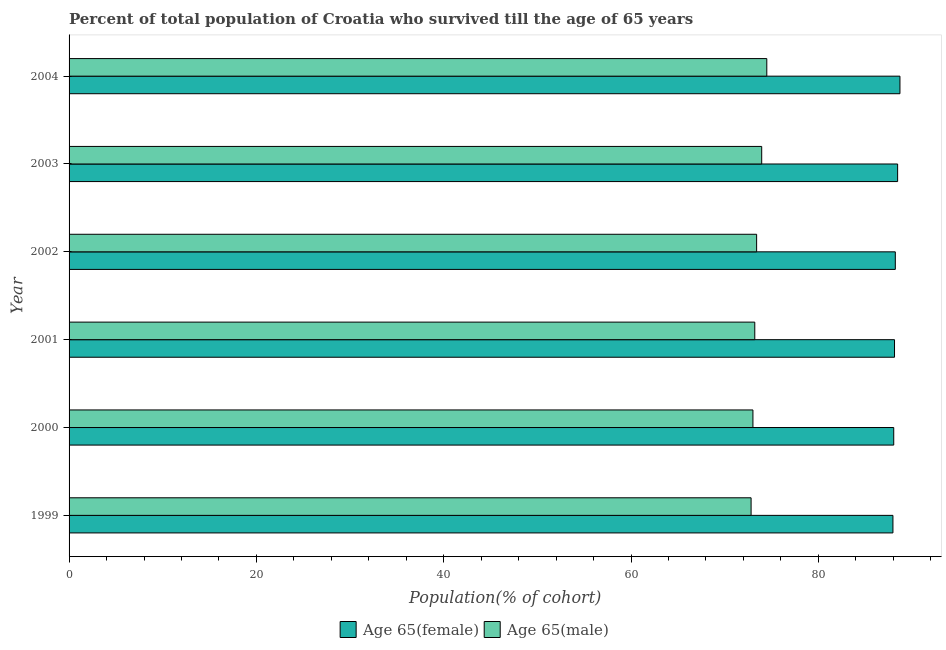How many different coloured bars are there?
Keep it short and to the point. 2. How many groups of bars are there?
Offer a terse response. 6. In how many cases, is the number of bars for a given year not equal to the number of legend labels?
Provide a short and direct response. 0. What is the percentage of male population who survived till age of 65 in 2000?
Provide a short and direct response. 73.02. Across all years, what is the maximum percentage of female population who survived till age of 65?
Ensure brevity in your answer.  88.71. Across all years, what is the minimum percentage of male population who survived till age of 65?
Offer a very short reply. 72.82. In which year was the percentage of male population who survived till age of 65 maximum?
Your answer should be compact. 2004. What is the total percentage of male population who survived till age of 65 in the graph?
Provide a short and direct response. 440.91. What is the difference between the percentage of male population who survived till age of 65 in 2001 and that in 2004?
Ensure brevity in your answer.  -1.28. What is the difference between the percentage of male population who survived till age of 65 in 2002 and the percentage of female population who survived till age of 65 in 2004?
Offer a terse response. -15.3. What is the average percentage of male population who survived till age of 65 per year?
Your answer should be compact. 73.48. In the year 2003, what is the difference between the percentage of female population who survived till age of 65 and percentage of male population who survived till age of 65?
Make the answer very short. 14.51. Is the percentage of male population who survived till age of 65 in 2002 less than that in 2004?
Your response must be concise. Yes. Is the difference between the percentage of male population who survived till age of 65 in 2001 and 2002 greater than the difference between the percentage of female population who survived till age of 65 in 2001 and 2002?
Your response must be concise. No. What is the difference between the highest and the second highest percentage of female population who survived till age of 65?
Make the answer very short. 0.25. What is the difference between the highest and the lowest percentage of male population who survived till age of 65?
Your answer should be compact. 1.68. Is the sum of the percentage of female population who survived till age of 65 in 1999 and 2003 greater than the maximum percentage of male population who survived till age of 65 across all years?
Your answer should be compact. Yes. What does the 2nd bar from the top in 2002 represents?
Provide a short and direct response. Age 65(female). What does the 1st bar from the bottom in 1999 represents?
Offer a very short reply. Age 65(female). How many bars are there?
Keep it short and to the point. 12. How many years are there in the graph?
Make the answer very short. 6. What is the difference between two consecutive major ticks on the X-axis?
Your response must be concise. 20. Does the graph contain any zero values?
Provide a succinct answer. No. Does the graph contain grids?
Provide a short and direct response. No. Where does the legend appear in the graph?
Your answer should be compact. Bottom center. How are the legend labels stacked?
Offer a terse response. Horizontal. What is the title of the graph?
Ensure brevity in your answer.  Percent of total population of Croatia who survived till the age of 65 years. Does "Urban agglomerations" appear as one of the legend labels in the graph?
Make the answer very short. No. What is the label or title of the X-axis?
Provide a short and direct response. Population(% of cohort). What is the Population(% of cohort) in Age 65(female) in 1999?
Make the answer very short. 87.96. What is the Population(% of cohort) of Age 65(male) in 1999?
Offer a terse response. 72.82. What is the Population(% of cohort) in Age 65(female) in 2000?
Make the answer very short. 88.05. What is the Population(% of cohort) in Age 65(male) in 2000?
Your answer should be very brief. 73.02. What is the Population(% of cohort) in Age 65(female) in 2001?
Keep it short and to the point. 88.13. What is the Population(% of cohort) of Age 65(male) in 2001?
Provide a succinct answer. 73.21. What is the Population(% of cohort) in Age 65(female) in 2002?
Give a very brief answer. 88.22. What is the Population(% of cohort) in Age 65(male) in 2002?
Ensure brevity in your answer.  73.41. What is the Population(% of cohort) of Age 65(female) in 2003?
Your answer should be very brief. 88.47. What is the Population(% of cohort) in Age 65(male) in 2003?
Ensure brevity in your answer.  73.95. What is the Population(% of cohort) of Age 65(female) in 2004?
Offer a very short reply. 88.71. What is the Population(% of cohort) of Age 65(male) in 2004?
Offer a very short reply. 74.5. Across all years, what is the maximum Population(% of cohort) in Age 65(female)?
Keep it short and to the point. 88.71. Across all years, what is the maximum Population(% of cohort) of Age 65(male)?
Provide a succinct answer. 74.5. Across all years, what is the minimum Population(% of cohort) of Age 65(female)?
Make the answer very short. 87.96. Across all years, what is the minimum Population(% of cohort) in Age 65(male)?
Your response must be concise. 72.82. What is the total Population(% of cohort) of Age 65(female) in the graph?
Provide a succinct answer. 529.54. What is the total Population(% of cohort) of Age 65(male) in the graph?
Your answer should be very brief. 440.91. What is the difference between the Population(% of cohort) of Age 65(female) in 1999 and that in 2000?
Offer a terse response. -0.08. What is the difference between the Population(% of cohort) of Age 65(male) in 1999 and that in 2000?
Provide a short and direct response. -0.2. What is the difference between the Population(% of cohort) in Age 65(female) in 1999 and that in 2001?
Offer a very short reply. -0.17. What is the difference between the Population(% of cohort) of Age 65(male) in 1999 and that in 2001?
Ensure brevity in your answer.  -0.39. What is the difference between the Population(% of cohort) in Age 65(female) in 1999 and that in 2002?
Ensure brevity in your answer.  -0.25. What is the difference between the Population(% of cohort) of Age 65(male) in 1999 and that in 2002?
Your answer should be very brief. -0.59. What is the difference between the Population(% of cohort) of Age 65(female) in 1999 and that in 2003?
Offer a very short reply. -0.5. What is the difference between the Population(% of cohort) of Age 65(male) in 1999 and that in 2003?
Your response must be concise. -1.13. What is the difference between the Population(% of cohort) of Age 65(female) in 1999 and that in 2004?
Offer a terse response. -0.75. What is the difference between the Population(% of cohort) in Age 65(male) in 1999 and that in 2004?
Offer a very short reply. -1.68. What is the difference between the Population(% of cohort) in Age 65(female) in 2000 and that in 2001?
Offer a terse response. -0.08. What is the difference between the Population(% of cohort) of Age 65(male) in 2000 and that in 2001?
Ensure brevity in your answer.  -0.2. What is the difference between the Population(% of cohort) in Age 65(female) in 2000 and that in 2002?
Give a very brief answer. -0.17. What is the difference between the Population(% of cohort) in Age 65(male) in 2000 and that in 2002?
Give a very brief answer. -0.39. What is the difference between the Population(% of cohort) in Age 65(female) in 2000 and that in 2003?
Give a very brief answer. -0.42. What is the difference between the Population(% of cohort) in Age 65(male) in 2000 and that in 2003?
Ensure brevity in your answer.  -0.94. What is the difference between the Population(% of cohort) in Age 65(female) in 2000 and that in 2004?
Offer a terse response. -0.66. What is the difference between the Population(% of cohort) in Age 65(male) in 2000 and that in 2004?
Keep it short and to the point. -1.48. What is the difference between the Population(% of cohort) of Age 65(female) in 2001 and that in 2002?
Your answer should be compact. -0.08. What is the difference between the Population(% of cohort) in Age 65(male) in 2001 and that in 2002?
Offer a terse response. -0.2. What is the difference between the Population(% of cohort) in Age 65(female) in 2001 and that in 2003?
Offer a very short reply. -0.33. What is the difference between the Population(% of cohort) in Age 65(male) in 2001 and that in 2003?
Give a very brief answer. -0.74. What is the difference between the Population(% of cohort) of Age 65(female) in 2001 and that in 2004?
Your answer should be very brief. -0.58. What is the difference between the Population(% of cohort) in Age 65(male) in 2001 and that in 2004?
Offer a very short reply. -1.28. What is the difference between the Population(% of cohort) of Age 65(female) in 2002 and that in 2003?
Ensure brevity in your answer.  -0.25. What is the difference between the Population(% of cohort) in Age 65(male) in 2002 and that in 2003?
Your response must be concise. -0.54. What is the difference between the Population(% of cohort) in Age 65(female) in 2002 and that in 2004?
Your answer should be very brief. -0.5. What is the difference between the Population(% of cohort) of Age 65(male) in 2002 and that in 2004?
Provide a succinct answer. -1.09. What is the difference between the Population(% of cohort) of Age 65(female) in 2003 and that in 2004?
Give a very brief answer. -0.25. What is the difference between the Population(% of cohort) of Age 65(male) in 2003 and that in 2004?
Offer a very short reply. -0.54. What is the difference between the Population(% of cohort) in Age 65(female) in 1999 and the Population(% of cohort) in Age 65(male) in 2000?
Your response must be concise. 14.95. What is the difference between the Population(% of cohort) of Age 65(female) in 1999 and the Population(% of cohort) of Age 65(male) in 2001?
Keep it short and to the point. 14.75. What is the difference between the Population(% of cohort) in Age 65(female) in 1999 and the Population(% of cohort) in Age 65(male) in 2002?
Your response must be concise. 14.55. What is the difference between the Population(% of cohort) in Age 65(female) in 1999 and the Population(% of cohort) in Age 65(male) in 2003?
Give a very brief answer. 14.01. What is the difference between the Population(% of cohort) of Age 65(female) in 1999 and the Population(% of cohort) of Age 65(male) in 2004?
Give a very brief answer. 13.47. What is the difference between the Population(% of cohort) of Age 65(female) in 2000 and the Population(% of cohort) of Age 65(male) in 2001?
Provide a short and direct response. 14.84. What is the difference between the Population(% of cohort) of Age 65(female) in 2000 and the Population(% of cohort) of Age 65(male) in 2002?
Provide a short and direct response. 14.64. What is the difference between the Population(% of cohort) of Age 65(female) in 2000 and the Population(% of cohort) of Age 65(male) in 2003?
Offer a terse response. 14.1. What is the difference between the Population(% of cohort) in Age 65(female) in 2000 and the Population(% of cohort) in Age 65(male) in 2004?
Your response must be concise. 13.55. What is the difference between the Population(% of cohort) of Age 65(female) in 2001 and the Population(% of cohort) of Age 65(male) in 2002?
Keep it short and to the point. 14.72. What is the difference between the Population(% of cohort) in Age 65(female) in 2001 and the Population(% of cohort) in Age 65(male) in 2003?
Give a very brief answer. 14.18. What is the difference between the Population(% of cohort) of Age 65(female) in 2001 and the Population(% of cohort) of Age 65(male) in 2004?
Provide a succinct answer. 13.64. What is the difference between the Population(% of cohort) in Age 65(female) in 2002 and the Population(% of cohort) in Age 65(male) in 2003?
Your response must be concise. 14.26. What is the difference between the Population(% of cohort) of Age 65(female) in 2002 and the Population(% of cohort) of Age 65(male) in 2004?
Your response must be concise. 13.72. What is the difference between the Population(% of cohort) in Age 65(female) in 2003 and the Population(% of cohort) in Age 65(male) in 2004?
Keep it short and to the point. 13.97. What is the average Population(% of cohort) in Age 65(female) per year?
Your answer should be very brief. 88.26. What is the average Population(% of cohort) of Age 65(male) per year?
Keep it short and to the point. 73.49. In the year 1999, what is the difference between the Population(% of cohort) in Age 65(female) and Population(% of cohort) in Age 65(male)?
Give a very brief answer. 15.14. In the year 2000, what is the difference between the Population(% of cohort) of Age 65(female) and Population(% of cohort) of Age 65(male)?
Provide a short and direct response. 15.03. In the year 2001, what is the difference between the Population(% of cohort) in Age 65(female) and Population(% of cohort) in Age 65(male)?
Your answer should be very brief. 14.92. In the year 2002, what is the difference between the Population(% of cohort) of Age 65(female) and Population(% of cohort) of Age 65(male)?
Keep it short and to the point. 14.81. In the year 2003, what is the difference between the Population(% of cohort) in Age 65(female) and Population(% of cohort) in Age 65(male)?
Provide a succinct answer. 14.51. In the year 2004, what is the difference between the Population(% of cohort) of Age 65(female) and Population(% of cohort) of Age 65(male)?
Offer a very short reply. 14.22. What is the ratio of the Population(% of cohort) in Age 65(male) in 1999 to that in 2000?
Keep it short and to the point. 1. What is the ratio of the Population(% of cohort) in Age 65(female) in 1999 to that in 2001?
Give a very brief answer. 1. What is the ratio of the Population(% of cohort) in Age 65(female) in 1999 to that in 2002?
Provide a succinct answer. 1. What is the ratio of the Population(% of cohort) in Age 65(male) in 1999 to that in 2003?
Give a very brief answer. 0.98. What is the ratio of the Population(% of cohort) of Age 65(male) in 1999 to that in 2004?
Provide a succinct answer. 0.98. What is the ratio of the Population(% of cohort) of Age 65(female) in 2000 to that in 2001?
Make the answer very short. 1. What is the ratio of the Population(% of cohort) of Age 65(male) in 2000 to that in 2001?
Offer a terse response. 1. What is the ratio of the Population(% of cohort) in Age 65(male) in 2000 to that in 2002?
Your answer should be compact. 0.99. What is the ratio of the Population(% of cohort) in Age 65(female) in 2000 to that in 2003?
Offer a very short reply. 1. What is the ratio of the Population(% of cohort) in Age 65(male) in 2000 to that in 2003?
Ensure brevity in your answer.  0.99. What is the ratio of the Population(% of cohort) of Age 65(male) in 2000 to that in 2004?
Your answer should be compact. 0.98. What is the ratio of the Population(% of cohort) of Age 65(female) in 2001 to that in 2002?
Offer a terse response. 1. What is the ratio of the Population(% of cohort) in Age 65(male) in 2001 to that in 2002?
Give a very brief answer. 1. What is the ratio of the Population(% of cohort) in Age 65(male) in 2001 to that in 2003?
Keep it short and to the point. 0.99. What is the ratio of the Population(% of cohort) in Age 65(female) in 2001 to that in 2004?
Make the answer very short. 0.99. What is the ratio of the Population(% of cohort) of Age 65(male) in 2001 to that in 2004?
Your answer should be compact. 0.98. What is the ratio of the Population(% of cohort) in Age 65(female) in 2002 to that in 2003?
Your answer should be very brief. 1. What is the ratio of the Population(% of cohort) of Age 65(female) in 2002 to that in 2004?
Provide a short and direct response. 0.99. What is the ratio of the Population(% of cohort) of Age 65(male) in 2002 to that in 2004?
Your response must be concise. 0.99. What is the ratio of the Population(% of cohort) in Age 65(female) in 2003 to that in 2004?
Your answer should be compact. 1. What is the ratio of the Population(% of cohort) of Age 65(male) in 2003 to that in 2004?
Ensure brevity in your answer.  0.99. What is the difference between the highest and the second highest Population(% of cohort) in Age 65(female)?
Your answer should be compact. 0.25. What is the difference between the highest and the second highest Population(% of cohort) of Age 65(male)?
Offer a terse response. 0.54. What is the difference between the highest and the lowest Population(% of cohort) in Age 65(female)?
Your answer should be compact. 0.75. What is the difference between the highest and the lowest Population(% of cohort) in Age 65(male)?
Offer a very short reply. 1.68. 